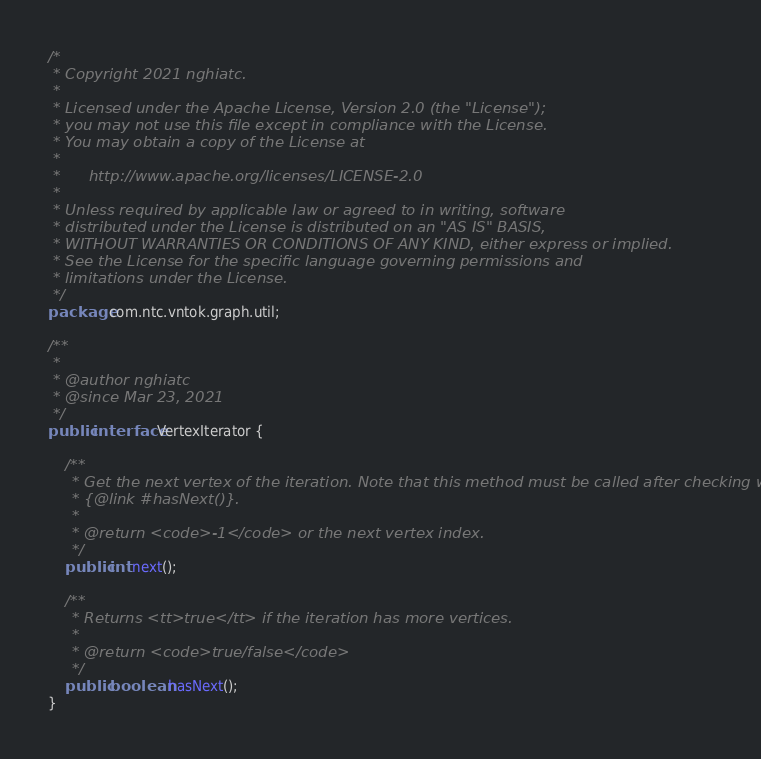Convert code to text. <code><loc_0><loc_0><loc_500><loc_500><_Java_>/*
 * Copyright 2021 nghiatc.
 *
 * Licensed under the Apache License, Version 2.0 (the "License");
 * you may not use this file except in compliance with the License.
 * You may obtain a copy of the License at
 *
 *      http://www.apache.org/licenses/LICENSE-2.0
 *
 * Unless required by applicable law or agreed to in writing, software
 * distributed under the License is distributed on an "AS IS" BASIS,
 * WITHOUT WARRANTIES OR CONDITIONS OF ANY KIND, either express or implied.
 * See the License for the specific language governing permissions and
 * limitations under the License.
 */
package com.ntc.vntok.graph.util;

/**
 *
 * @author nghiatc
 * @since Mar 23, 2021
 */
public interface VertexIterator {

    /**
     * Get the next vertex of the iteration. Note that this method must be called after checking with
     * {@link #hasNext()}.
     *
     * @return <code>-1</code> or the next vertex index.
     */
    public int next();

    /**
     * Returns <tt>true</tt> if the iteration has more vertices.
     *
     * @return <code>true/false</code>
     */
    public boolean hasNext();
}
</code> 